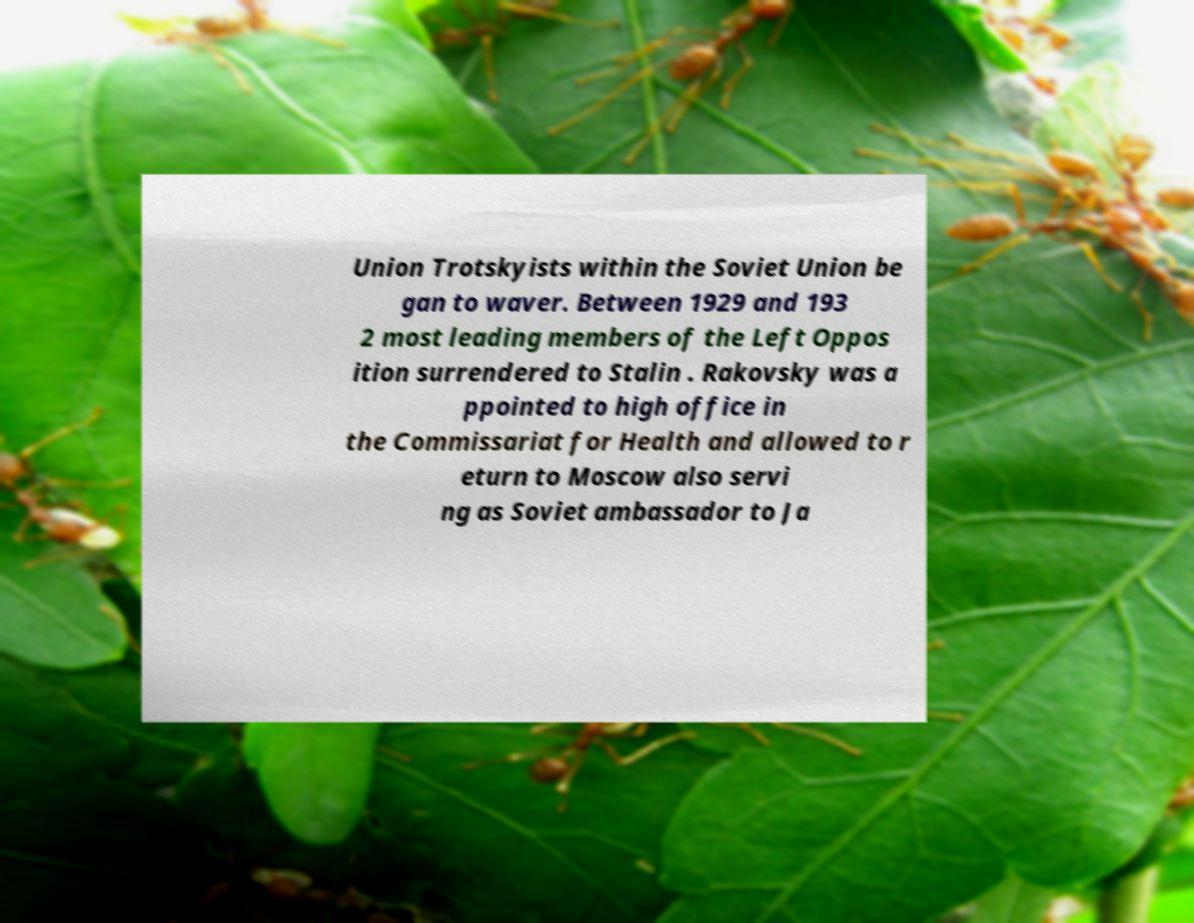Could you assist in decoding the text presented in this image and type it out clearly? Union Trotskyists within the Soviet Union be gan to waver. Between 1929 and 193 2 most leading members of the Left Oppos ition surrendered to Stalin . Rakovsky was a ppointed to high office in the Commissariat for Health and allowed to r eturn to Moscow also servi ng as Soviet ambassador to Ja 